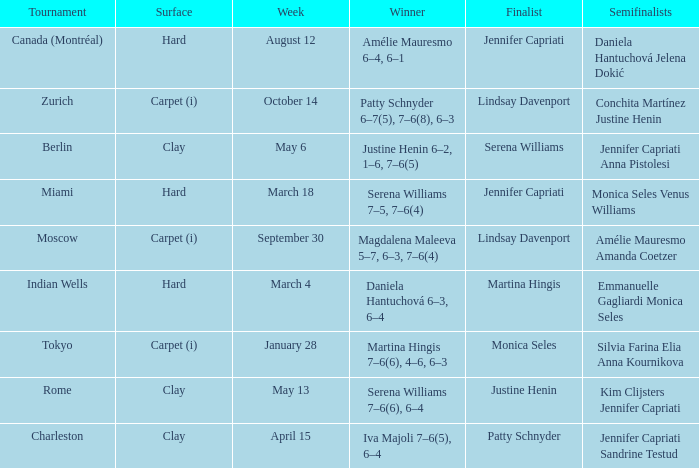What was the surface for finalist Justine Henin? Clay. 